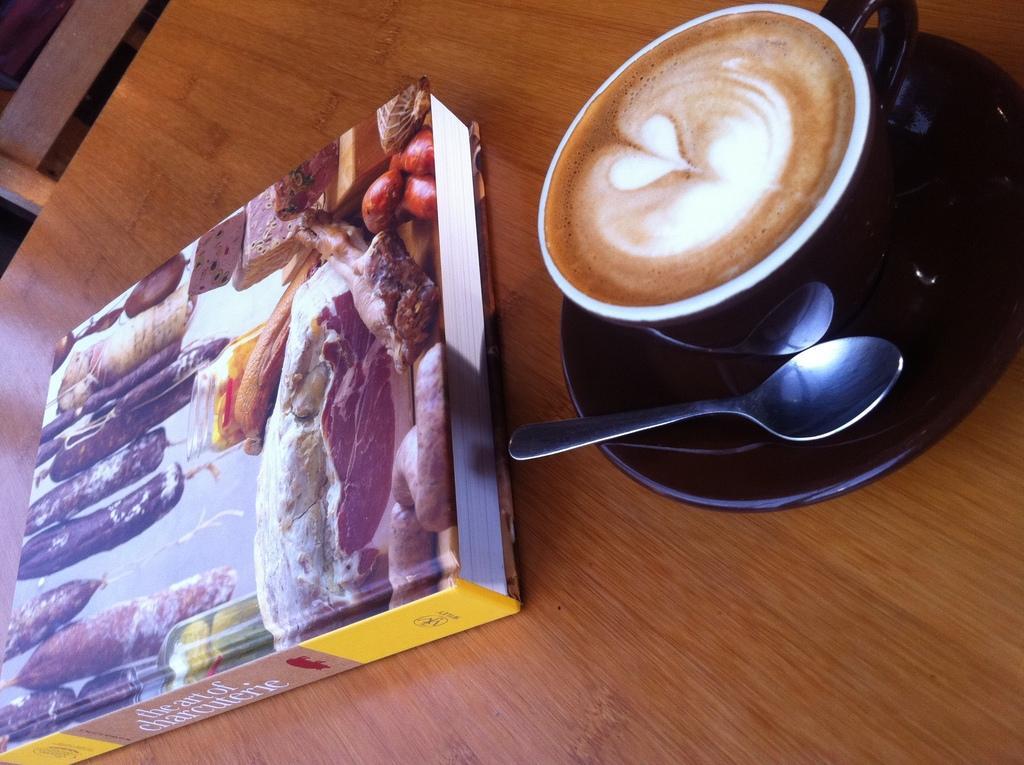In one or two sentences, can you explain what this image depicts? In this picture I see the brown color surface on which there is a book and I see a picture on which there is food and I see something is written and on the right side of this image I see a saucer on which there is a cup and I see liquid in it which is of white and brown in color and I see a spoon on the saucer. 